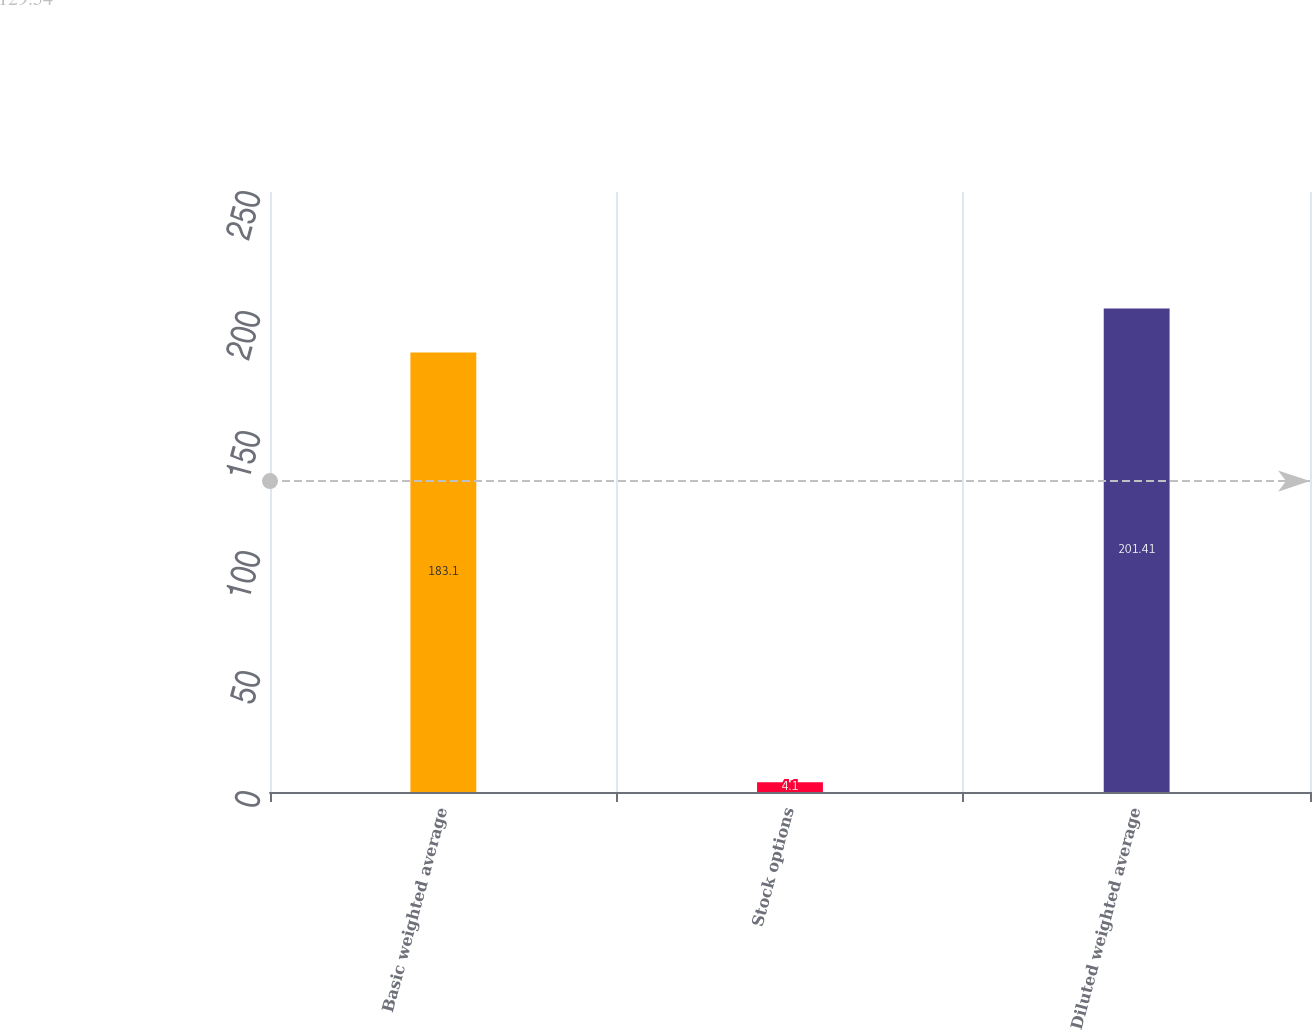Convert chart. <chart><loc_0><loc_0><loc_500><loc_500><bar_chart><fcel>Basic weighted average<fcel>Stock options<fcel>Diluted weighted average<nl><fcel>183.1<fcel>4.1<fcel>201.41<nl></chart> 